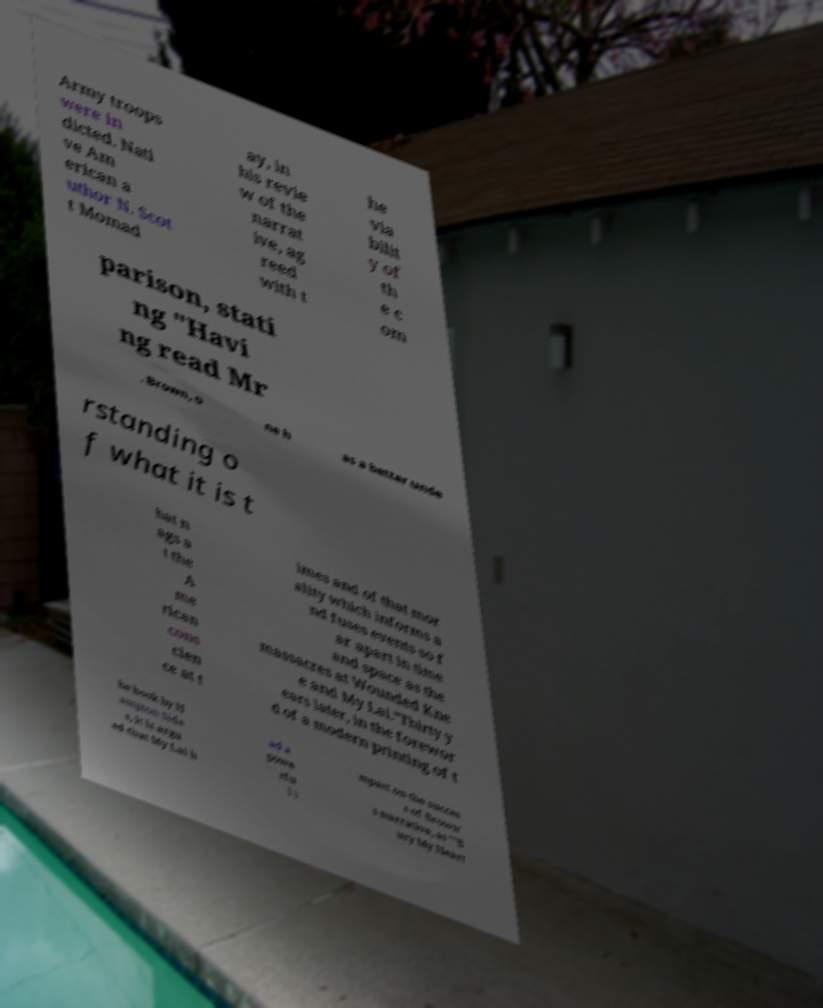Can you accurately transcribe the text from the provided image for me? Army troops were in dicted. Nati ve Am erican a uthor N. Scot t Momad ay, in his revie w of the narrat ive, ag reed with t he via bilit y of th e c om parison, stati ng "Havi ng read Mr . Brown, o ne h as a better unde rstanding o f what it is t hat n ags a t the A me rican cons cien ce at t imes and of that mor ality which informs a nd fuses events so f ar apart in time and space as the massacres at Wounded Kne e and My Lai."Thirty y ears later, in the forewor d of a modern printing of t he book by H ampton Side s, it is argu ed that My Lai h ad a powe rfu l i mpact on the succes s of Brown' s narrative, as ""B ury My Heart 